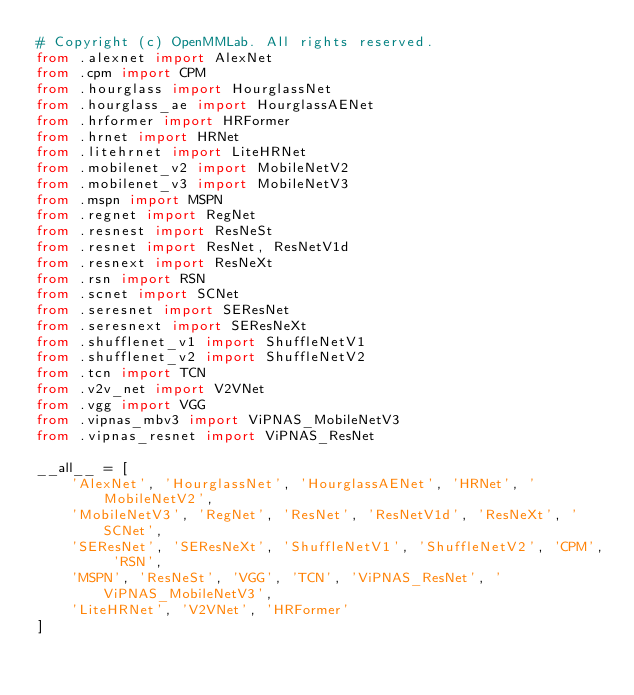<code> <loc_0><loc_0><loc_500><loc_500><_Python_># Copyright (c) OpenMMLab. All rights reserved.
from .alexnet import AlexNet
from .cpm import CPM
from .hourglass import HourglassNet
from .hourglass_ae import HourglassAENet
from .hrformer import HRFormer
from .hrnet import HRNet
from .litehrnet import LiteHRNet
from .mobilenet_v2 import MobileNetV2
from .mobilenet_v3 import MobileNetV3
from .mspn import MSPN
from .regnet import RegNet
from .resnest import ResNeSt
from .resnet import ResNet, ResNetV1d
from .resnext import ResNeXt
from .rsn import RSN
from .scnet import SCNet
from .seresnet import SEResNet
from .seresnext import SEResNeXt
from .shufflenet_v1 import ShuffleNetV1
from .shufflenet_v2 import ShuffleNetV2
from .tcn import TCN
from .v2v_net import V2VNet
from .vgg import VGG
from .vipnas_mbv3 import ViPNAS_MobileNetV3
from .vipnas_resnet import ViPNAS_ResNet

__all__ = [
    'AlexNet', 'HourglassNet', 'HourglassAENet', 'HRNet', 'MobileNetV2',
    'MobileNetV3', 'RegNet', 'ResNet', 'ResNetV1d', 'ResNeXt', 'SCNet',
    'SEResNet', 'SEResNeXt', 'ShuffleNetV1', 'ShuffleNetV2', 'CPM', 'RSN',
    'MSPN', 'ResNeSt', 'VGG', 'TCN', 'ViPNAS_ResNet', 'ViPNAS_MobileNetV3',
    'LiteHRNet', 'V2VNet', 'HRFormer'
]
</code> 